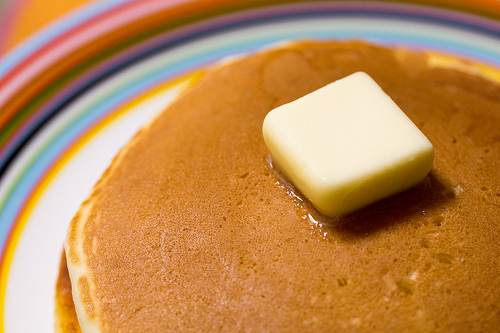<image>
Is the butter on the plate? No. The butter is not positioned on the plate. They may be near each other, but the butter is not supported by or resting on top of the plate. 